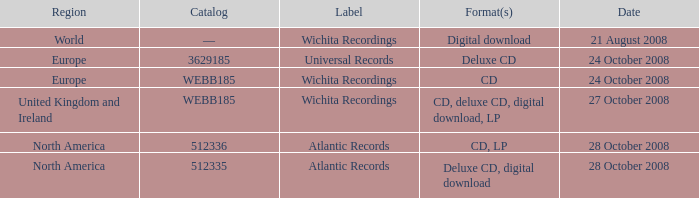Which formats have a region of Europe and Catalog value of WEBB185? CD. 